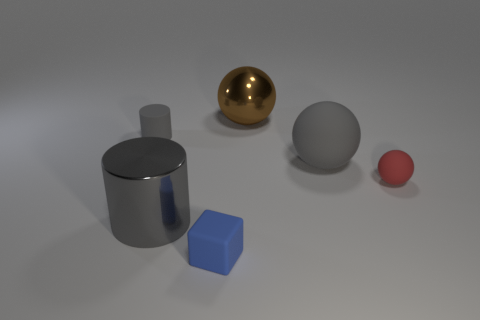Do the tiny object on the left side of the large gray cylinder and the gray shiny object have the same shape?
Make the answer very short. Yes. What number of big objects are metal cylinders or blue balls?
Ensure brevity in your answer.  1. Are there an equal number of small cylinders that are to the left of the small blue rubber block and gray things left of the big gray shiny thing?
Offer a terse response. Yes. How many other objects are there of the same color as the big rubber object?
Your response must be concise. 2. Do the big shiny cylinder and the large shiny object that is behind the large cylinder have the same color?
Your answer should be very brief. No. What number of gray objects are rubber things or matte cubes?
Offer a very short reply. 2. Are there the same number of brown metallic spheres that are in front of the cube and gray rubber balls?
Offer a terse response. No. What color is the other small object that is the same shape as the brown thing?
Make the answer very short. Red. How many gray rubber objects have the same shape as the small red rubber object?
Keep it short and to the point. 1. What is the material of the other cylinder that is the same color as the small matte cylinder?
Your answer should be very brief. Metal. 